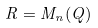Convert formula to latex. <formula><loc_0><loc_0><loc_500><loc_500>R = M _ { n } ( Q )</formula> 